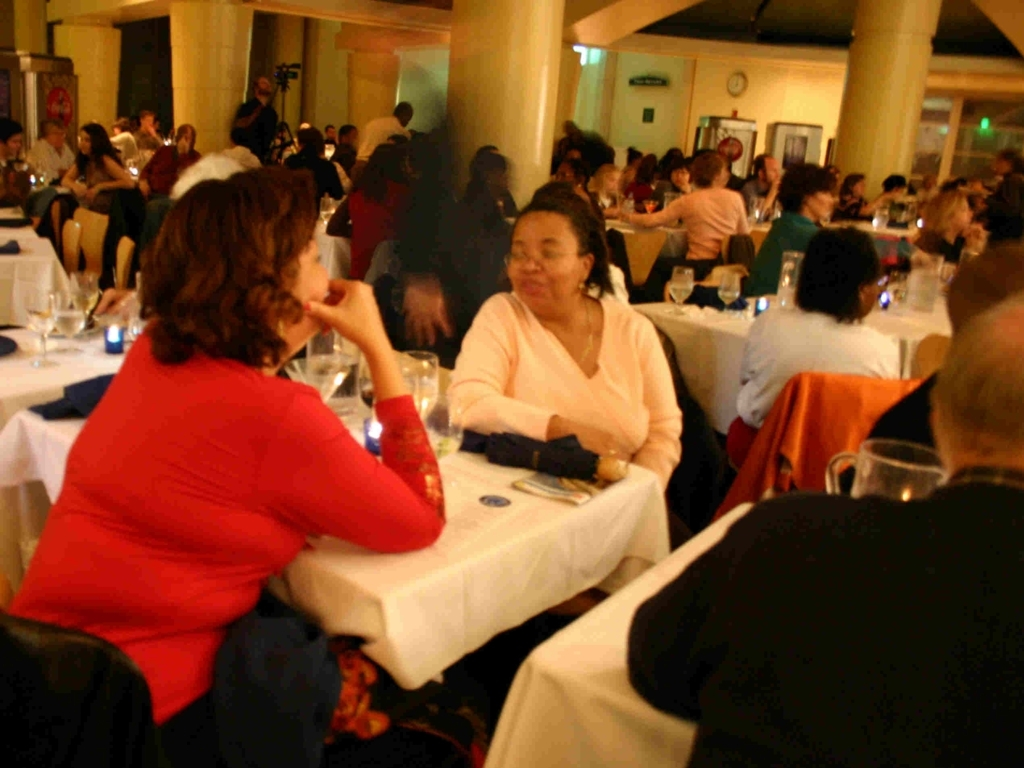What is the level of blurriness of the features of the crowd in the background?
A. Sharp
B. Clear
C. Blurred
Answer with the option's letter from the given choices directly.
 C. 